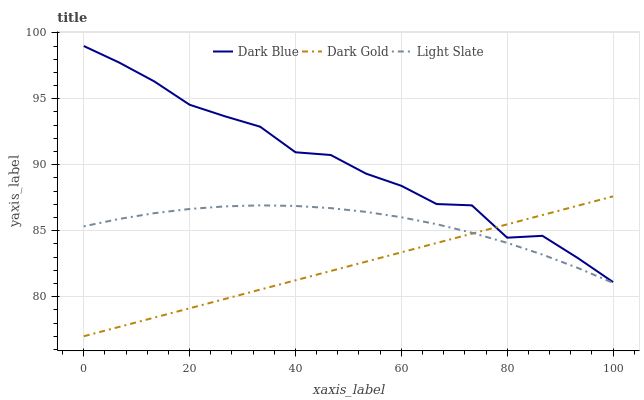Does Dark Blue have the minimum area under the curve?
Answer yes or no. No. Does Dark Gold have the maximum area under the curve?
Answer yes or no. No. Is Dark Blue the smoothest?
Answer yes or no. No. Is Dark Gold the roughest?
Answer yes or no. No. Does Dark Blue have the lowest value?
Answer yes or no. No. Does Dark Gold have the highest value?
Answer yes or no. No. Is Light Slate less than Dark Blue?
Answer yes or no. Yes. Is Dark Blue greater than Light Slate?
Answer yes or no. Yes. Does Light Slate intersect Dark Blue?
Answer yes or no. No. 